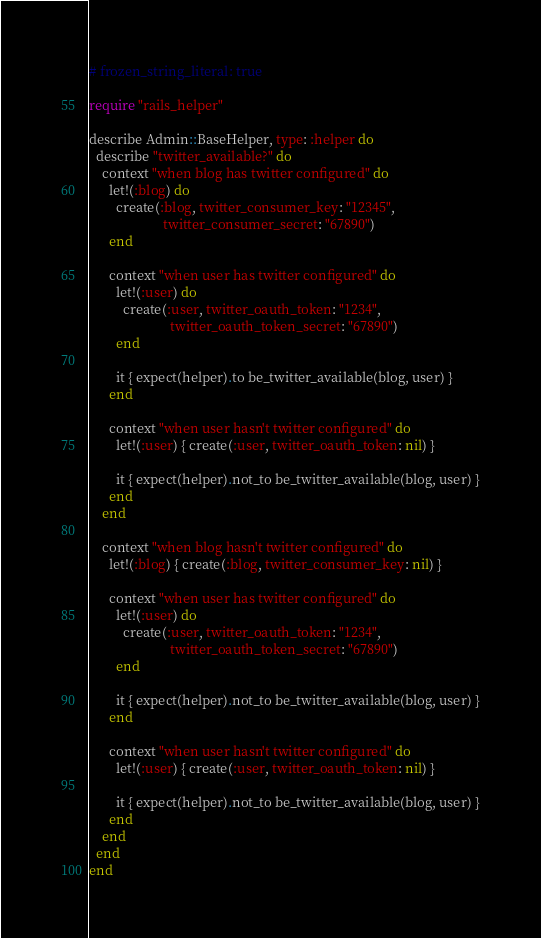<code> <loc_0><loc_0><loc_500><loc_500><_Ruby_># frozen_string_literal: true

require "rails_helper"

describe Admin::BaseHelper, type: :helper do
  describe "twitter_available?" do
    context "when blog has twitter configured" do
      let!(:blog) do
        create(:blog, twitter_consumer_key: "12345",
                      twitter_consumer_secret: "67890")
      end

      context "when user has twitter configured" do
        let!(:user) do
          create(:user, twitter_oauth_token: "1234",
                        twitter_oauth_token_secret: "67890")
        end

        it { expect(helper).to be_twitter_available(blog, user) }
      end

      context "when user hasn't twitter configured" do
        let!(:user) { create(:user, twitter_oauth_token: nil) }

        it { expect(helper).not_to be_twitter_available(blog, user) }
      end
    end

    context "when blog hasn't twitter configured" do
      let!(:blog) { create(:blog, twitter_consumer_key: nil) }

      context "when user has twitter configured" do
        let!(:user) do
          create(:user, twitter_oauth_token: "1234",
                        twitter_oauth_token_secret: "67890")
        end

        it { expect(helper).not_to be_twitter_available(blog, user) }
      end

      context "when user hasn't twitter configured" do
        let!(:user) { create(:user, twitter_oauth_token: nil) }

        it { expect(helper).not_to be_twitter_available(blog, user) }
      end
    end
  end
end
</code> 